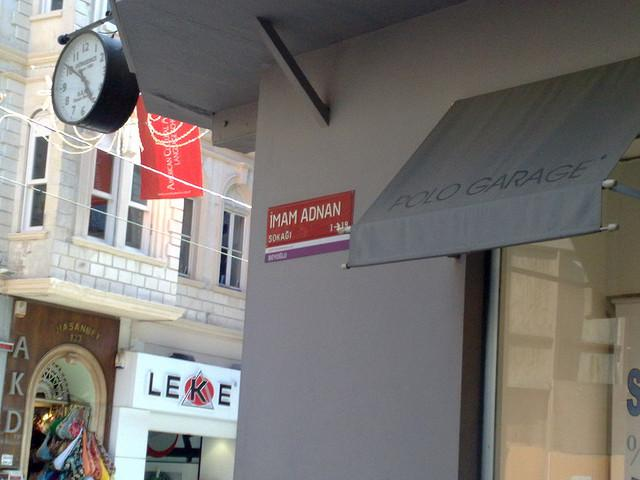What is the name of the Garage? Please explain your reasoning. polo. A garage sign hangs above a business. 